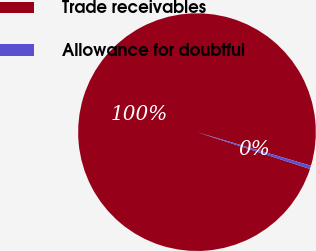<chart> <loc_0><loc_0><loc_500><loc_500><pie_chart><fcel>Trade receivables<fcel>Allowance for doubtful<nl><fcel>99.55%<fcel>0.45%<nl></chart> 